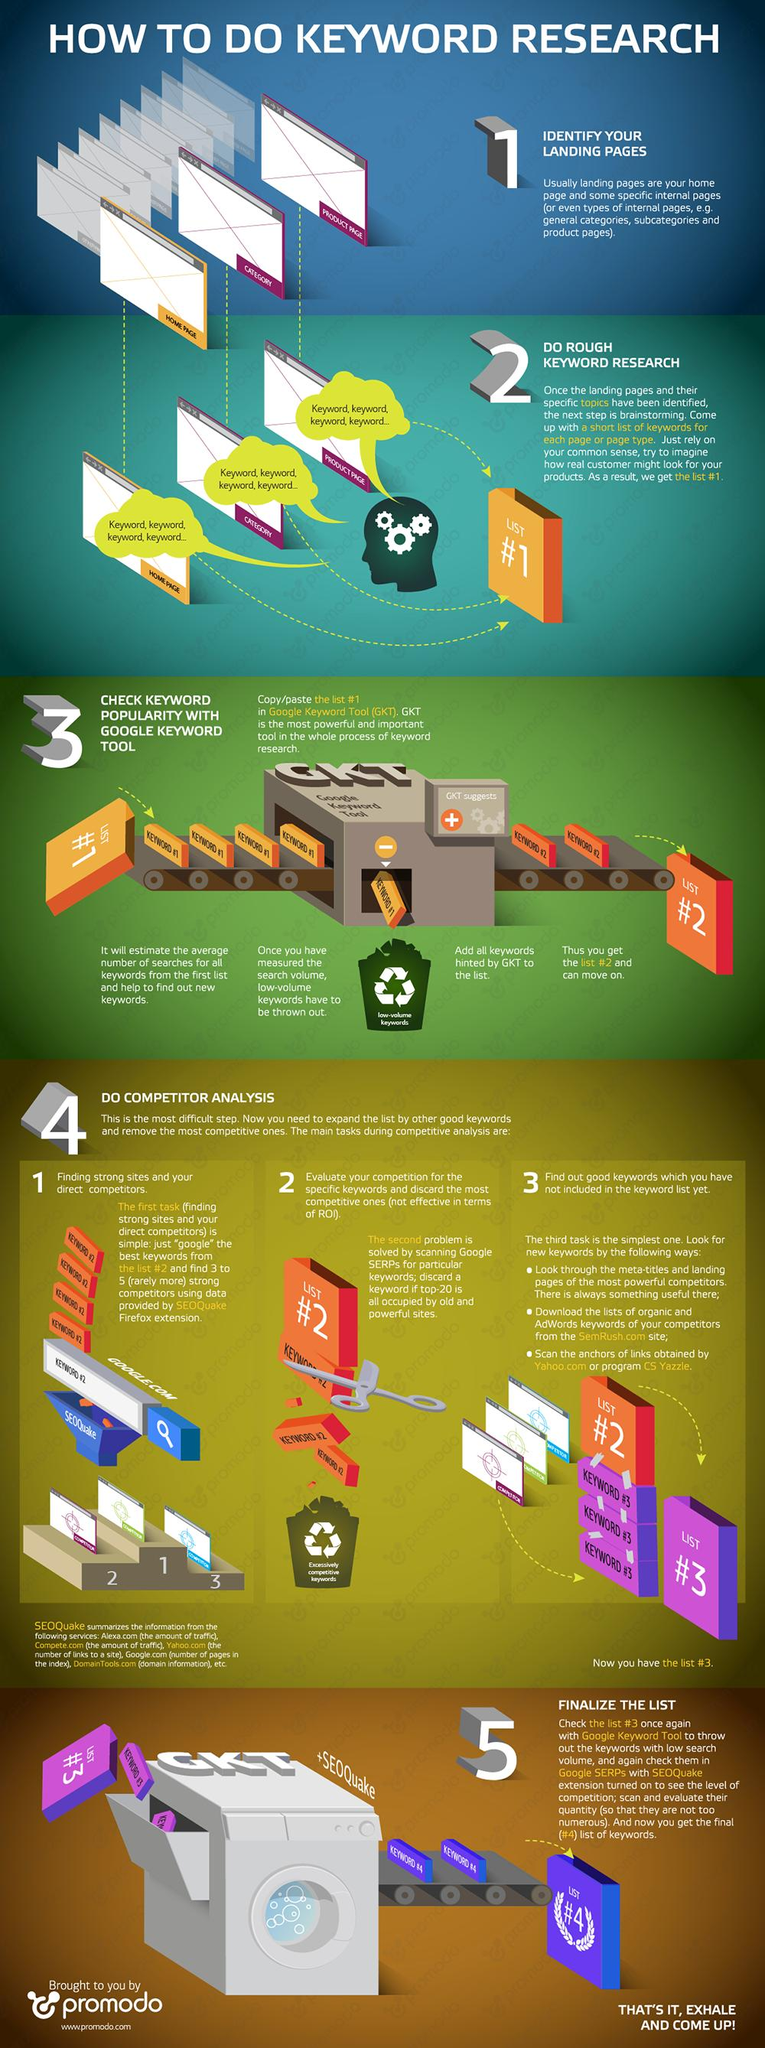Specify some key components in this picture. There are three points under the heading "Do a competitor analysis. 